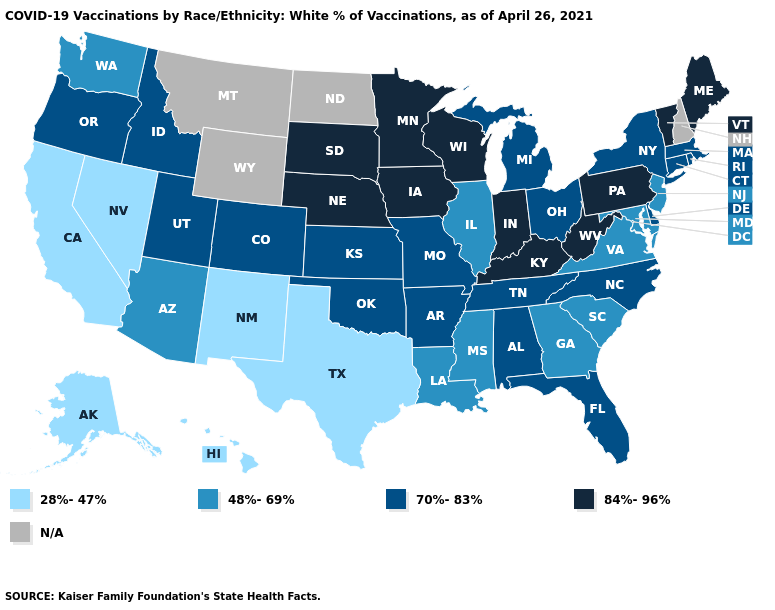Which states hav the highest value in the Northeast?
Short answer required. Maine, Pennsylvania, Vermont. What is the value of Louisiana?
Answer briefly. 48%-69%. Among the states that border Illinois , which have the lowest value?
Give a very brief answer. Missouri. What is the lowest value in the USA?
Answer briefly. 28%-47%. What is the value of Minnesota?
Answer briefly. 84%-96%. Name the states that have a value in the range 48%-69%?
Answer briefly. Arizona, Georgia, Illinois, Louisiana, Maryland, Mississippi, New Jersey, South Carolina, Virginia, Washington. Name the states that have a value in the range 28%-47%?
Keep it brief. Alaska, California, Hawaii, Nevada, New Mexico, Texas. Name the states that have a value in the range 70%-83%?
Concise answer only. Alabama, Arkansas, Colorado, Connecticut, Delaware, Florida, Idaho, Kansas, Massachusetts, Michigan, Missouri, New York, North Carolina, Ohio, Oklahoma, Oregon, Rhode Island, Tennessee, Utah. Name the states that have a value in the range N/A?
Answer briefly. Montana, New Hampshire, North Dakota, Wyoming. Name the states that have a value in the range 84%-96%?
Quick response, please. Indiana, Iowa, Kentucky, Maine, Minnesota, Nebraska, Pennsylvania, South Dakota, Vermont, West Virginia, Wisconsin. Name the states that have a value in the range 48%-69%?
Quick response, please. Arizona, Georgia, Illinois, Louisiana, Maryland, Mississippi, New Jersey, South Carolina, Virginia, Washington. Does Missouri have the highest value in the MidWest?
Give a very brief answer. No. Does Texas have the lowest value in the USA?
Keep it brief. Yes. 